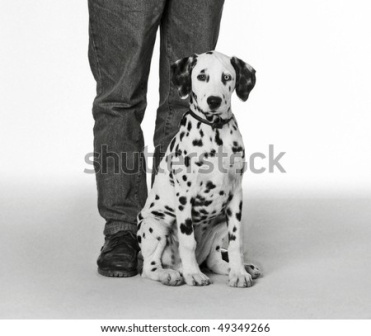Imagine the puppy as a famous detective. What would its first mystery be? In a bustling city where secrets lurked in every shadow, Detective Paws, the renowned Dalmatian detective, was called to his first big case. The prestigious Canine Crown, worn by the leaders of the annual dog show, had mysteriously vanished. Detective Paws, with his keen sense of smell and unparalleled observation skills, began his investigation at the scene of the crime. He noted the faint scent of peanut butter leading to the garden. Following the trail, he discovered a network of underground tunnels used by a mischievous raccoon gang infamous for their heists. With cunning and bravery, Detective Paws confronted the gang, retrieved the stolen Crown, and returned it just in time for the show. The city celebrated Detective Paws, hailing him as a hero who could solve any mystery with his loyalty and wit. 